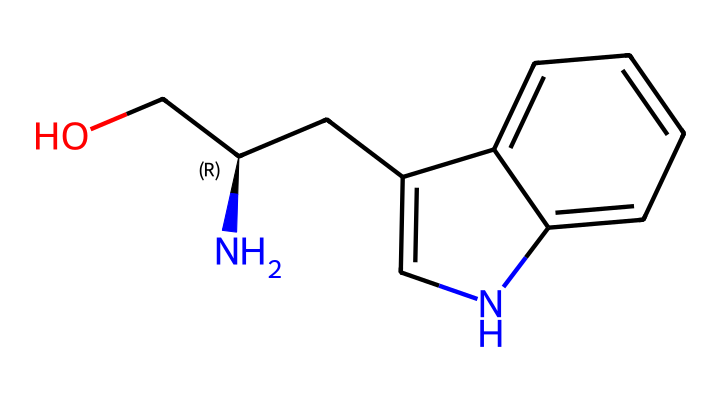What is the molecular formula of this drug? To find the molecular formula, count the number of each type of atom in the SMILES representation. There are two oxygen atoms (O), one nitrogen atom (N), and fourteen carbon atoms (C), as well as eighteen hydrogen atoms (H). This gives the formula: C14H18N2O.
Answer: C14H18N2O How many rings are present in this chemical structure? By analyzing the structure derived from the SMILES, we can see two connected rings in the bicyclic structure, which means there are two rings present.
Answer: 2 What functional group is indicated by the oxygen in this chemical? The presence of an -OH group, which consists of a carbon atom bonded to a hydroxyl group (OH), indicates that this chemical has an alcohol functional group.
Answer: alcohol Which atom in this structure is characteristic of its role in mood regulation? The nitrogen atom (N) in the structure is significant as it is often involved in neurotransmitter functions and is related to serotonin, which plays a vital role in mood regulation.
Answer: nitrogen What does the presence of the indole ring suggest about this drug's properties? The structure includes an indole (a bicyclic compound containing a benzene ring fused to a pyrrole) which is characteristic of many psychoactive compounds, indicating potential effects on serotonin receptors.
Answer: psychoactive properties Does this chemical have a chiral center? Yes, the carbon atom with the stereochemical designation “C@” indicates it has a specific spatial arrangement of substituents, confirming the presence of a chiral center that can exhibit enantiomerism.
Answer: yes 